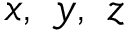<formula> <loc_0><loc_0><loc_500><loc_500>x , \ y , \ z</formula> 